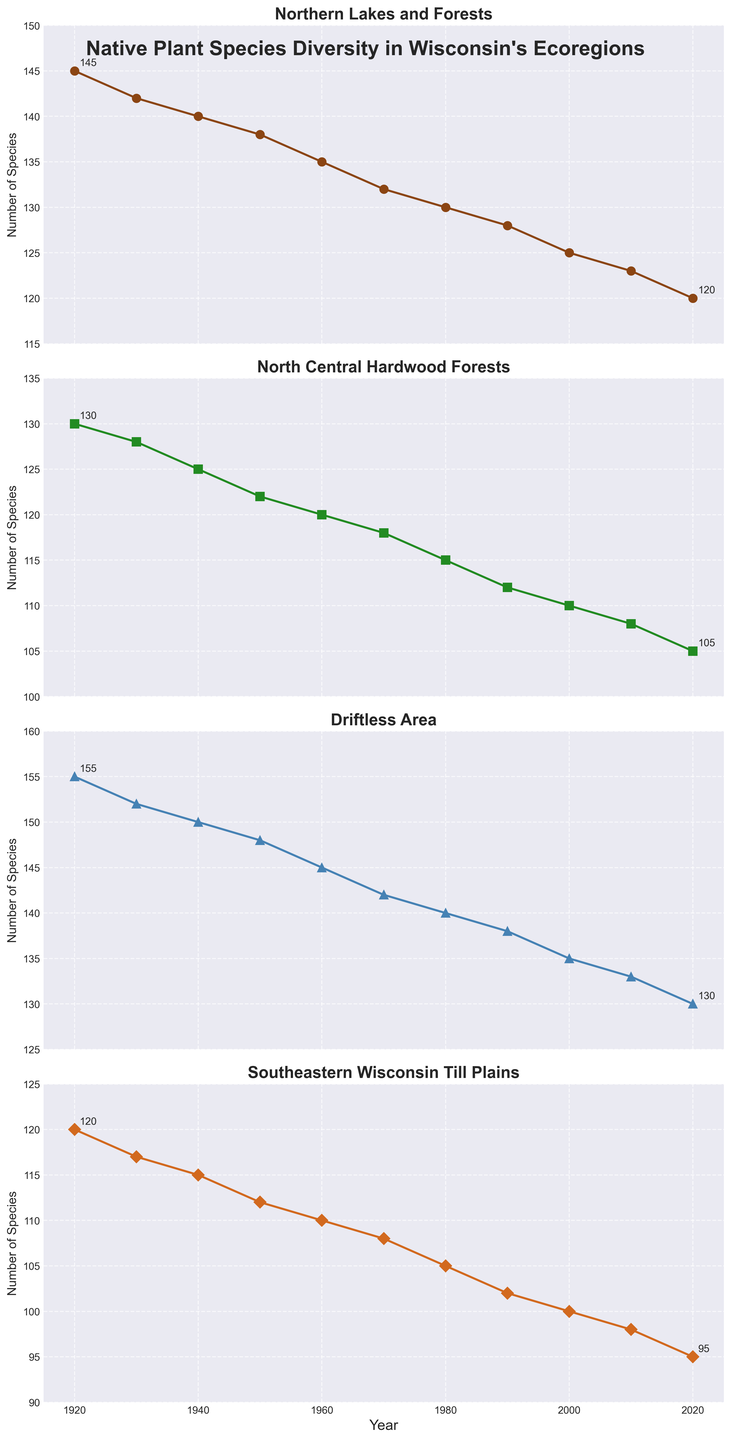What's the range of species diversity for the Driftless Area from 1920 to 2020? To find the range, subtract the minimum number of species in the Driftless Area (2020) from the maximum number (1920). The range is 155 - 130 = 25.
Answer: 25 Which ecoregion showed the greatest decline in species diversity from 1920 to 2020? Calculate the difference in species diversity for each ecoregion between 1920 and 2020. The Northern Lakes and Forests declined from 145 to 120 (25), North Central Hardwood Forests from 130 to 105 (25), Driftless Area from 155 to 130 (25), and Southeastern Wisconsin Till Plains from 120 to 95 (25). All ecoregions showed an equal decline of 25 species.
Answer: Northern Lakes and Forests, North Central Hardwood Forests, Driftless Area, Southeastern Wisconsin Till Plains (tie) Which ecoregion had the highest species diversity in 1950? Look at the values for each ecoregion in 1950: Northern Lakes and Forests had 138 species, North Central Hardwood Forests had 122, Driftless Area had 148, and Southeastern Wisconsin Till Plains had 112. The Driftless Area had the highest number of species, at 148.
Answer: Driftless Area Between 1940 and 1980, which ecoregion had the smallest decline in species diversity? Calculate the difference for each ecoregion between 1940 and 1980: Northern Lakes and Forests declined from 140 to 130 (10), North Central Hardwood Forests from 125 to 115 (10), Driftless Area from 150 to 140 (10), Southeastern Wisconsin Till Plains from 115 to 105 (10). All ecoregions had the same decline of 10 species.
Answer: Northern Lakes and Forests, North Central Hardwood Forests, Driftless Area, Southeastern Wisconsin Till Plains (tie) On the graph, which ecoregion is represented by a line with circular markers? The circular markers correspond to the Northern Lakes and Forests ecoregion based on the plot details.
Answer: Northern Lakes and Forests What trend can you identify in the species diversity for all ecoregions from 1920 to 2020? All ecoregions show a consistent declining trend in species diversity over the century.
Answer: Decline 